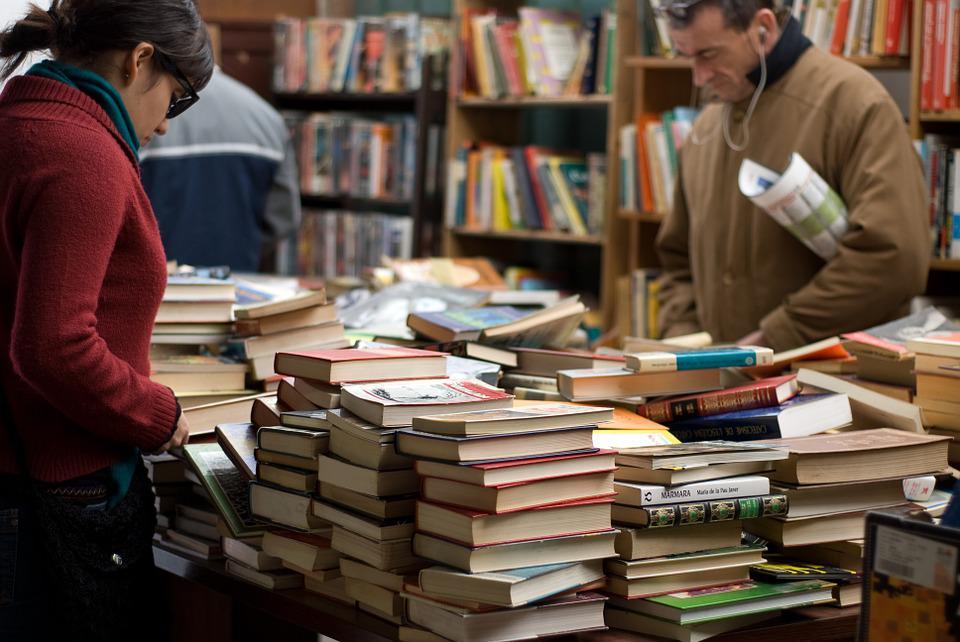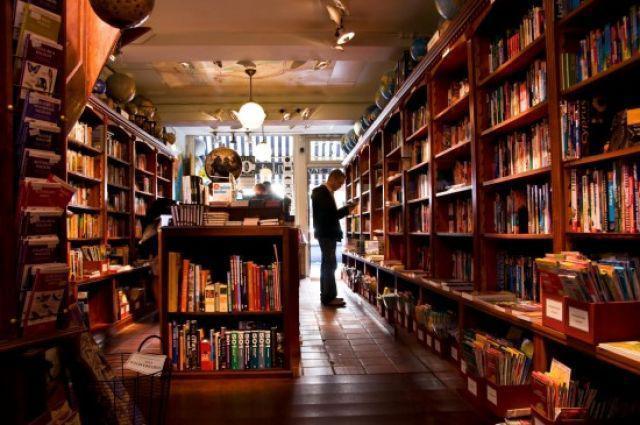The first image is the image on the left, the second image is the image on the right. Assess this claim about the two images: "The right image includes people sitting on opposite sides of a table with bookshelves in the background.". Correct or not? Answer yes or no. No. The first image is the image on the left, the second image is the image on the right. Assess this claim about the two images: "In at least one image there is an empty bookstore with at least 1 plant.". Correct or not? Answer yes or no. No. 